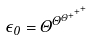<formula> <loc_0><loc_0><loc_500><loc_500>\epsilon _ { 0 } = \Theta ^ { \Theta ^ { \Theta ^ { + ^ { + ^ { + } } } } }</formula> 